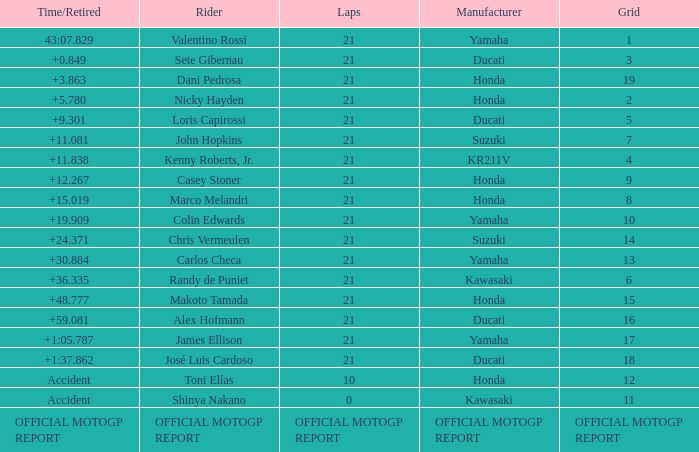Which rider had a time/retired od +19.909? Colin Edwards. Would you mind parsing the complete table? {'header': ['Time/Retired', 'Rider', 'Laps', 'Manufacturer', 'Grid'], 'rows': [['43:07.829', 'Valentino Rossi', '21', 'Yamaha', '1'], ['+0.849', 'Sete Gibernau', '21', 'Ducati', '3'], ['+3.863', 'Dani Pedrosa', '21', 'Honda', '19'], ['+5.780', 'Nicky Hayden', '21', 'Honda', '2'], ['+9.301', 'Loris Capirossi', '21', 'Ducati', '5'], ['+11.081', 'John Hopkins', '21', 'Suzuki', '7'], ['+11.838', 'Kenny Roberts, Jr.', '21', 'KR211V', '4'], ['+12.267', 'Casey Stoner', '21', 'Honda', '9'], ['+15.019', 'Marco Melandri', '21', 'Honda', '8'], ['+19.909', 'Colin Edwards', '21', 'Yamaha', '10'], ['+24.371', 'Chris Vermeulen', '21', 'Suzuki', '14'], ['+30.884', 'Carlos Checa', '21', 'Yamaha', '13'], ['+36.335', 'Randy de Puniet', '21', 'Kawasaki', '6'], ['+48.777', 'Makoto Tamada', '21', 'Honda', '15'], ['+59.081', 'Alex Hofmann', '21', 'Ducati', '16'], ['+1:05.787', 'James Ellison', '21', 'Yamaha', '17'], ['+1:37.862', 'José Luis Cardoso', '21', 'Ducati', '18'], ['Accident', 'Toni Elías', '10', 'Honda', '12'], ['Accident', 'Shinya Nakano', '0', 'Kawasaki', '11'], ['OFFICIAL MOTOGP REPORT', 'OFFICIAL MOTOGP REPORT', 'OFFICIAL MOTOGP REPORT', 'OFFICIAL MOTOGP REPORT', 'OFFICIAL MOTOGP REPORT']]} 